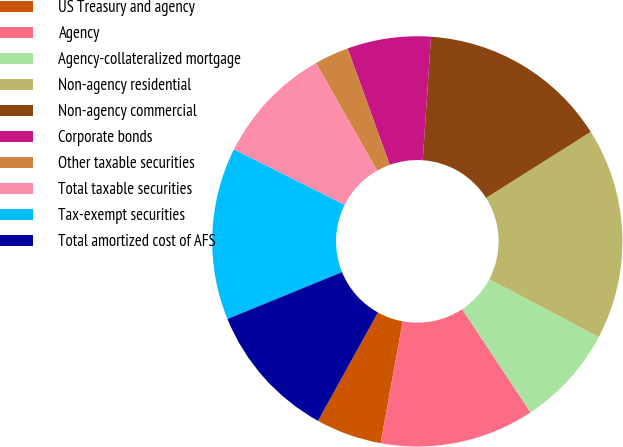Convert chart to OTSL. <chart><loc_0><loc_0><loc_500><loc_500><pie_chart><fcel>US Treasury and agency<fcel>Agency<fcel>Agency-collateralized mortgage<fcel>Non-agency residential<fcel>Non-agency commercial<fcel>Corporate bonds<fcel>Other taxable securities<fcel>Total taxable securities<fcel>Tax-exempt securities<fcel>Total amortized cost of AFS<nl><fcel>5.18%<fcel>12.17%<fcel>7.98%<fcel>16.68%<fcel>14.97%<fcel>6.58%<fcel>2.71%<fcel>9.38%<fcel>13.57%<fcel>10.78%<nl></chart> 